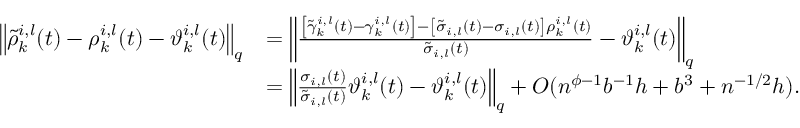<formula> <loc_0><loc_0><loc_500><loc_500>\begin{array} { r l } { \left \| \tilde { \rho } _ { k } ^ { i , l } ( t ) - \rho _ { k } ^ { i , l } ( t ) - \vartheta _ { k } ^ { i , l } ( t ) \right \| _ { q } } & { = \left \| \frac { \left [ \tilde { \gamma } _ { k } ^ { i , l } ( t ) - \gamma _ { k } ^ { i , l } ( t ) \right ] - \left [ \tilde { \sigma } _ { i , l } ( t ) - \sigma _ { i , l } ( t ) \right ] \rho _ { k } ^ { i , l } ( t ) } { \tilde { \sigma } _ { i , l } ( t ) } - \vartheta _ { k } ^ { i , l } ( t ) \right \| _ { q } } \\ & { = \left \| \frac { \sigma _ { i , l } ( t ) } { \tilde { \sigma } _ { i , l } ( t ) } \vartheta _ { k } ^ { i , l } ( t ) - \vartheta _ { k } ^ { i , l } ( t ) \right \| _ { q } + O ( n ^ { \phi - 1 } b ^ { - 1 } h + b ^ { 3 } + n ^ { - 1 / 2 } h ) . } \end{array}</formula> 